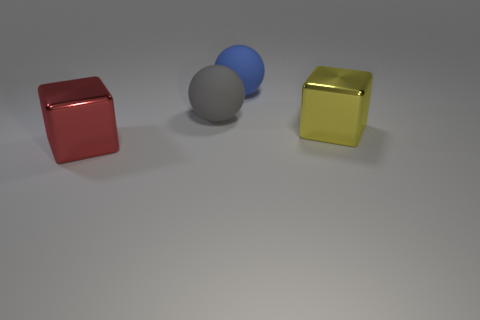What is the size of the yellow metallic thing that is the same shape as the big red metal thing?
Offer a terse response. Large. What number of other objects are the same material as the gray thing?
Make the answer very short. 1. Do the big gray thing and the big object that is behind the big gray matte thing have the same material?
Make the answer very short. Yes. Are there fewer gray rubber things behind the big gray ball than large objects on the right side of the yellow metal object?
Provide a short and direct response. No. There is a metal cube in front of the yellow metal cube; what is its color?
Provide a short and direct response. Red. Does the metallic thing behind the red metal thing have the same size as the red shiny thing?
Give a very brief answer. Yes. There is a yellow cube; how many big blocks are left of it?
Offer a terse response. 1. Is there a blue rubber thing that has the same size as the blue rubber sphere?
Offer a terse response. No. The big block left of the large metallic block that is behind the large red shiny cube is what color?
Provide a short and direct response. Red. What number of big things are both behind the big red metal block and left of the large blue ball?
Offer a very short reply. 1. 